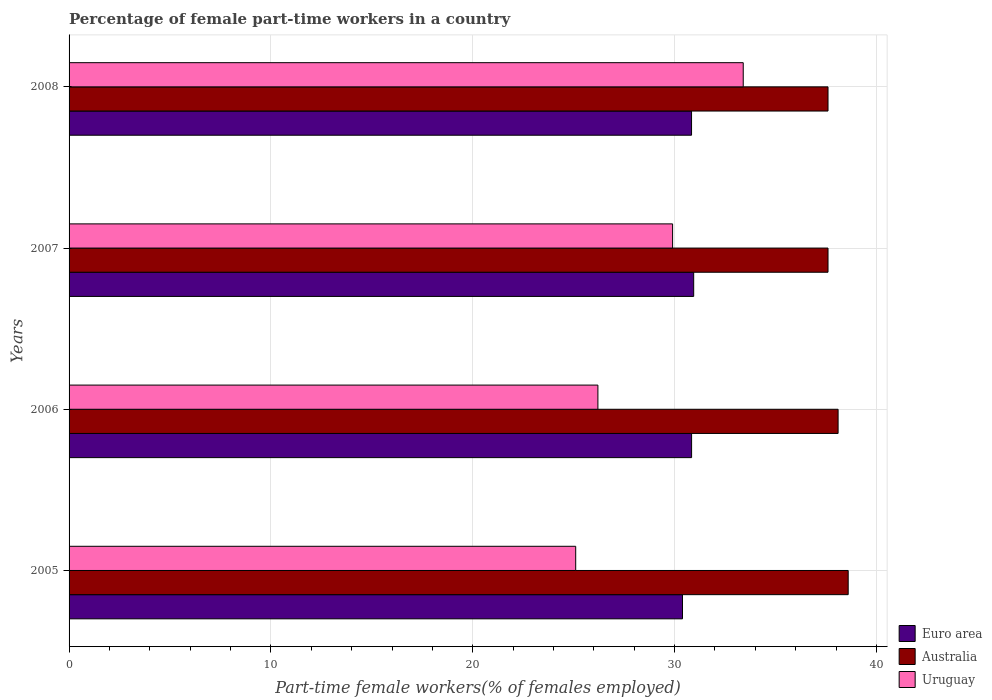How many different coloured bars are there?
Keep it short and to the point. 3. How many groups of bars are there?
Your answer should be very brief. 4. Are the number of bars on each tick of the Y-axis equal?
Your answer should be very brief. Yes. How many bars are there on the 2nd tick from the bottom?
Offer a very short reply. 3. What is the percentage of female part-time workers in Australia in 2005?
Give a very brief answer. 38.6. Across all years, what is the maximum percentage of female part-time workers in Uruguay?
Make the answer very short. 33.4. Across all years, what is the minimum percentage of female part-time workers in Australia?
Make the answer very short. 37.6. In which year was the percentage of female part-time workers in Euro area maximum?
Offer a very short reply. 2007. What is the total percentage of female part-time workers in Euro area in the graph?
Offer a terse response. 123.02. What is the difference between the percentage of female part-time workers in Euro area in 2005 and that in 2008?
Give a very brief answer. -0.45. What is the difference between the percentage of female part-time workers in Australia in 2008 and the percentage of female part-time workers in Euro area in 2007?
Keep it short and to the point. 6.65. What is the average percentage of female part-time workers in Australia per year?
Keep it short and to the point. 37.97. In the year 2005, what is the difference between the percentage of female part-time workers in Uruguay and percentage of female part-time workers in Euro area?
Give a very brief answer. -5.29. In how many years, is the percentage of female part-time workers in Uruguay greater than 16 %?
Ensure brevity in your answer.  4. Is the percentage of female part-time workers in Euro area in 2005 less than that in 2006?
Provide a succinct answer. Yes. What is the difference between the highest and the second highest percentage of female part-time workers in Uruguay?
Give a very brief answer. 3.5. In how many years, is the percentage of female part-time workers in Euro area greater than the average percentage of female part-time workers in Euro area taken over all years?
Make the answer very short. 3. What does the 1st bar from the bottom in 2005 represents?
Make the answer very short. Euro area. Is it the case that in every year, the sum of the percentage of female part-time workers in Euro area and percentage of female part-time workers in Australia is greater than the percentage of female part-time workers in Uruguay?
Your answer should be very brief. Yes. Are all the bars in the graph horizontal?
Give a very brief answer. Yes. What is the difference between two consecutive major ticks on the X-axis?
Keep it short and to the point. 10. Are the values on the major ticks of X-axis written in scientific E-notation?
Your answer should be very brief. No. Does the graph contain any zero values?
Your response must be concise. No. Does the graph contain grids?
Your answer should be very brief. Yes. How are the legend labels stacked?
Provide a short and direct response. Vertical. What is the title of the graph?
Provide a short and direct response. Percentage of female part-time workers in a country. Does "Korea (Democratic)" appear as one of the legend labels in the graph?
Make the answer very short. No. What is the label or title of the X-axis?
Make the answer very short. Part-time female workers(% of females employed). What is the Part-time female workers(% of females employed) of Euro area in 2005?
Provide a succinct answer. 30.39. What is the Part-time female workers(% of females employed) in Australia in 2005?
Offer a very short reply. 38.6. What is the Part-time female workers(% of females employed) of Uruguay in 2005?
Provide a succinct answer. 25.1. What is the Part-time female workers(% of females employed) of Euro area in 2006?
Your answer should be very brief. 30.84. What is the Part-time female workers(% of females employed) in Australia in 2006?
Your answer should be very brief. 38.1. What is the Part-time female workers(% of females employed) of Uruguay in 2006?
Provide a succinct answer. 26.2. What is the Part-time female workers(% of females employed) of Euro area in 2007?
Give a very brief answer. 30.95. What is the Part-time female workers(% of females employed) in Australia in 2007?
Your answer should be compact. 37.6. What is the Part-time female workers(% of females employed) of Uruguay in 2007?
Your answer should be very brief. 29.9. What is the Part-time female workers(% of females employed) in Euro area in 2008?
Your answer should be compact. 30.84. What is the Part-time female workers(% of females employed) in Australia in 2008?
Your answer should be very brief. 37.6. What is the Part-time female workers(% of females employed) in Uruguay in 2008?
Make the answer very short. 33.4. Across all years, what is the maximum Part-time female workers(% of females employed) in Euro area?
Your answer should be very brief. 30.95. Across all years, what is the maximum Part-time female workers(% of females employed) of Australia?
Your answer should be compact. 38.6. Across all years, what is the maximum Part-time female workers(% of females employed) of Uruguay?
Keep it short and to the point. 33.4. Across all years, what is the minimum Part-time female workers(% of females employed) in Euro area?
Provide a short and direct response. 30.39. Across all years, what is the minimum Part-time female workers(% of females employed) in Australia?
Make the answer very short. 37.6. Across all years, what is the minimum Part-time female workers(% of females employed) of Uruguay?
Your answer should be compact. 25.1. What is the total Part-time female workers(% of females employed) in Euro area in the graph?
Your response must be concise. 123.02. What is the total Part-time female workers(% of females employed) in Australia in the graph?
Your answer should be compact. 151.9. What is the total Part-time female workers(% of females employed) in Uruguay in the graph?
Ensure brevity in your answer.  114.6. What is the difference between the Part-time female workers(% of females employed) in Euro area in 2005 and that in 2006?
Provide a succinct answer. -0.45. What is the difference between the Part-time female workers(% of females employed) of Australia in 2005 and that in 2006?
Your response must be concise. 0.5. What is the difference between the Part-time female workers(% of females employed) of Euro area in 2005 and that in 2007?
Offer a terse response. -0.55. What is the difference between the Part-time female workers(% of females employed) in Australia in 2005 and that in 2007?
Keep it short and to the point. 1. What is the difference between the Part-time female workers(% of females employed) of Euro area in 2005 and that in 2008?
Keep it short and to the point. -0.45. What is the difference between the Part-time female workers(% of females employed) in Uruguay in 2005 and that in 2008?
Make the answer very short. -8.3. What is the difference between the Part-time female workers(% of females employed) of Euro area in 2006 and that in 2007?
Keep it short and to the point. -0.1. What is the difference between the Part-time female workers(% of females employed) in Australia in 2006 and that in 2007?
Keep it short and to the point. 0.5. What is the difference between the Part-time female workers(% of females employed) of Uruguay in 2006 and that in 2007?
Your answer should be very brief. -3.7. What is the difference between the Part-time female workers(% of females employed) of Euro area in 2006 and that in 2008?
Ensure brevity in your answer.  0. What is the difference between the Part-time female workers(% of females employed) of Euro area in 2007 and that in 2008?
Offer a very short reply. 0.11. What is the difference between the Part-time female workers(% of females employed) of Euro area in 2005 and the Part-time female workers(% of females employed) of Australia in 2006?
Keep it short and to the point. -7.71. What is the difference between the Part-time female workers(% of females employed) of Euro area in 2005 and the Part-time female workers(% of females employed) of Uruguay in 2006?
Provide a short and direct response. 4.19. What is the difference between the Part-time female workers(% of females employed) in Euro area in 2005 and the Part-time female workers(% of females employed) in Australia in 2007?
Provide a succinct answer. -7.21. What is the difference between the Part-time female workers(% of females employed) of Euro area in 2005 and the Part-time female workers(% of females employed) of Uruguay in 2007?
Your answer should be very brief. 0.49. What is the difference between the Part-time female workers(% of females employed) in Euro area in 2005 and the Part-time female workers(% of females employed) in Australia in 2008?
Your answer should be very brief. -7.21. What is the difference between the Part-time female workers(% of females employed) of Euro area in 2005 and the Part-time female workers(% of females employed) of Uruguay in 2008?
Keep it short and to the point. -3.01. What is the difference between the Part-time female workers(% of females employed) in Euro area in 2006 and the Part-time female workers(% of females employed) in Australia in 2007?
Give a very brief answer. -6.76. What is the difference between the Part-time female workers(% of females employed) in Euro area in 2006 and the Part-time female workers(% of females employed) in Uruguay in 2007?
Your answer should be compact. 0.94. What is the difference between the Part-time female workers(% of females employed) of Euro area in 2006 and the Part-time female workers(% of females employed) of Australia in 2008?
Keep it short and to the point. -6.76. What is the difference between the Part-time female workers(% of females employed) of Euro area in 2006 and the Part-time female workers(% of females employed) of Uruguay in 2008?
Make the answer very short. -2.56. What is the difference between the Part-time female workers(% of females employed) of Australia in 2006 and the Part-time female workers(% of females employed) of Uruguay in 2008?
Keep it short and to the point. 4.7. What is the difference between the Part-time female workers(% of females employed) in Euro area in 2007 and the Part-time female workers(% of females employed) in Australia in 2008?
Provide a short and direct response. -6.65. What is the difference between the Part-time female workers(% of females employed) of Euro area in 2007 and the Part-time female workers(% of females employed) of Uruguay in 2008?
Provide a short and direct response. -2.45. What is the difference between the Part-time female workers(% of females employed) of Australia in 2007 and the Part-time female workers(% of females employed) of Uruguay in 2008?
Your answer should be compact. 4.2. What is the average Part-time female workers(% of females employed) of Euro area per year?
Your answer should be compact. 30.75. What is the average Part-time female workers(% of females employed) of Australia per year?
Give a very brief answer. 37.98. What is the average Part-time female workers(% of females employed) in Uruguay per year?
Provide a short and direct response. 28.65. In the year 2005, what is the difference between the Part-time female workers(% of females employed) in Euro area and Part-time female workers(% of females employed) in Australia?
Give a very brief answer. -8.21. In the year 2005, what is the difference between the Part-time female workers(% of females employed) in Euro area and Part-time female workers(% of females employed) in Uruguay?
Provide a succinct answer. 5.29. In the year 2006, what is the difference between the Part-time female workers(% of females employed) in Euro area and Part-time female workers(% of females employed) in Australia?
Offer a very short reply. -7.26. In the year 2006, what is the difference between the Part-time female workers(% of females employed) in Euro area and Part-time female workers(% of females employed) in Uruguay?
Your answer should be very brief. 4.64. In the year 2007, what is the difference between the Part-time female workers(% of females employed) in Euro area and Part-time female workers(% of females employed) in Australia?
Your response must be concise. -6.65. In the year 2007, what is the difference between the Part-time female workers(% of females employed) in Euro area and Part-time female workers(% of females employed) in Uruguay?
Provide a short and direct response. 1.05. In the year 2008, what is the difference between the Part-time female workers(% of females employed) in Euro area and Part-time female workers(% of females employed) in Australia?
Give a very brief answer. -6.76. In the year 2008, what is the difference between the Part-time female workers(% of females employed) in Euro area and Part-time female workers(% of females employed) in Uruguay?
Ensure brevity in your answer.  -2.56. What is the ratio of the Part-time female workers(% of females employed) in Euro area in 2005 to that in 2006?
Keep it short and to the point. 0.99. What is the ratio of the Part-time female workers(% of females employed) of Australia in 2005 to that in 2006?
Your answer should be compact. 1.01. What is the ratio of the Part-time female workers(% of females employed) of Uruguay in 2005 to that in 2006?
Offer a terse response. 0.96. What is the ratio of the Part-time female workers(% of females employed) of Euro area in 2005 to that in 2007?
Your answer should be compact. 0.98. What is the ratio of the Part-time female workers(% of females employed) of Australia in 2005 to that in 2007?
Keep it short and to the point. 1.03. What is the ratio of the Part-time female workers(% of females employed) of Uruguay in 2005 to that in 2007?
Give a very brief answer. 0.84. What is the ratio of the Part-time female workers(% of females employed) in Euro area in 2005 to that in 2008?
Make the answer very short. 0.99. What is the ratio of the Part-time female workers(% of females employed) of Australia in 2005 to that in 2008?
Keep it short and to the point. 1.03. What is the ratio of the Part-time female workers(% of females employed) in Uruguay in 2005 to that in 2008?
Offer a terse response. 0.75. What is the ratio of the Part-time female workers(% of females employed) in Euro area in 2006 to that in 2007?
Your answer should be very brief. 1. What is the ratio of the Part-time female workers(% of females employed) of Australia in 2006 to that in 2007?
Give a very brief answer. 1.01. What is the ratio of the Part-time female workers(% of females employed) of Uruguay in 2006 to that in 2007?
Your response must be concise. 0.88. What is the ratio of the Part-time female workers(% of females employed) of Euro area in 2006 to that in 2008?
Make the answer very short. 1. What is the ratio of the Part-time female workers(% of females employed) in Australia in 2006 to that in 2008?
Your response must be concise. 1.01. What is the ratio of the Part-time female workers(% of females employed) in Uruguay in 2006 to that in 2008?
Your answer should be compact. 0.78. What is the ratio of the Part-time female workers(% of females employed) of Uruguay in 2007 to that in 2008?
Offer a terse response. 0.9. What is the difference between the highest and the second highest Part-time female workers(% of females employed) of Euro area?
Give a very brief answer. 0.1. What is the difference between the highest and the lowest Part-time female workers(% of females employed) in Euro area?
Provide a short and direct response. 0.55. What is the difference between the highest and the lowest Part-time female workers(% of females employed) in Australia?
Give a very brief answer. 1. What is the difference between the highest and the lowest Part-time female workers(% of females employed) of Uruguay?
Your answer should be very brief. 8.3. 